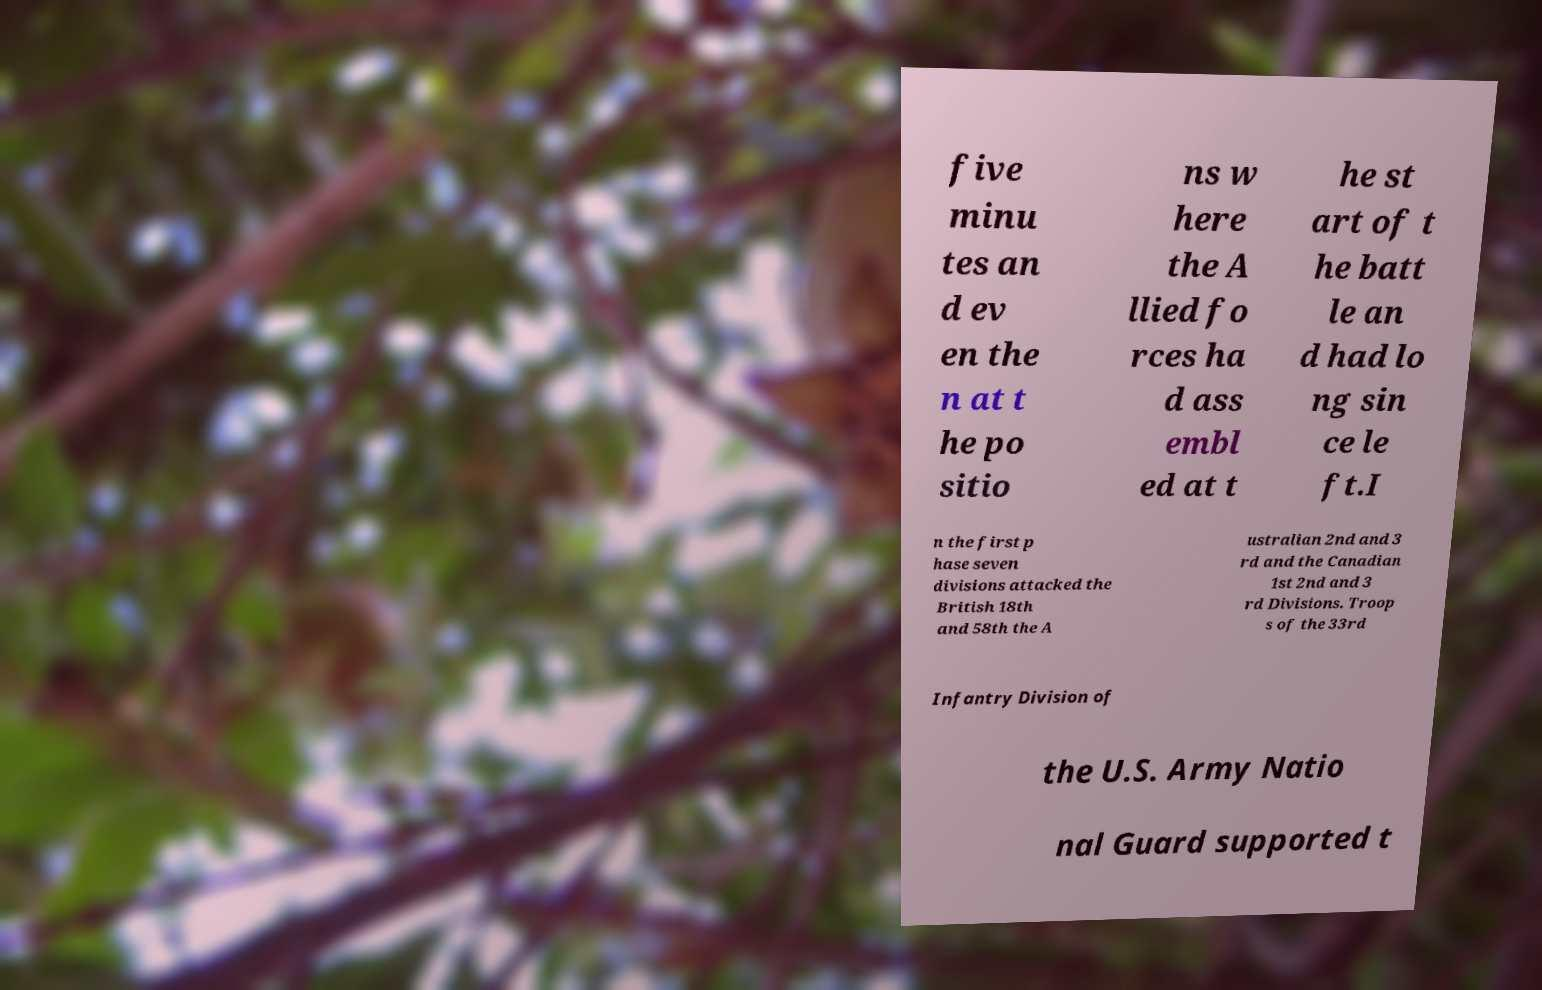Please identify and transcribe the text found in this image. five minu tes an d ev en the n at t he po sitio ns w here the A llied fo rces ha d ass embl ed at t he st art of t he batt le an d had lo ng sin ce le ft.I n the first p hase seven divisions attacked the British 18th and 58th the A ustralian 2nd and 3 rd and the Canadian 1st 2nd and 3 rd Divisions. Troop s of the 33rd Infantry Division of the U.S. Army Natio nal Guard supported t 